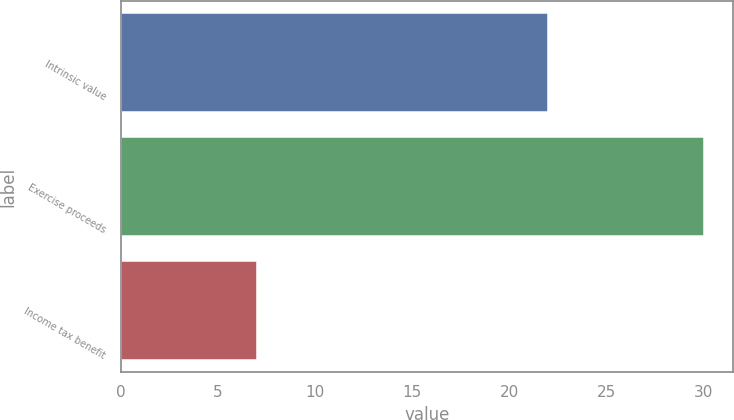Convert chart. <chart><loc_0><loc_0><loc_500><loc_500><bar_chart><fcel>Intrinsic value<fcel>Exercise proceeds<fcel>Income tax benefit<nl><fcel>22<fcel>30<fcel>7<nl></chart> 